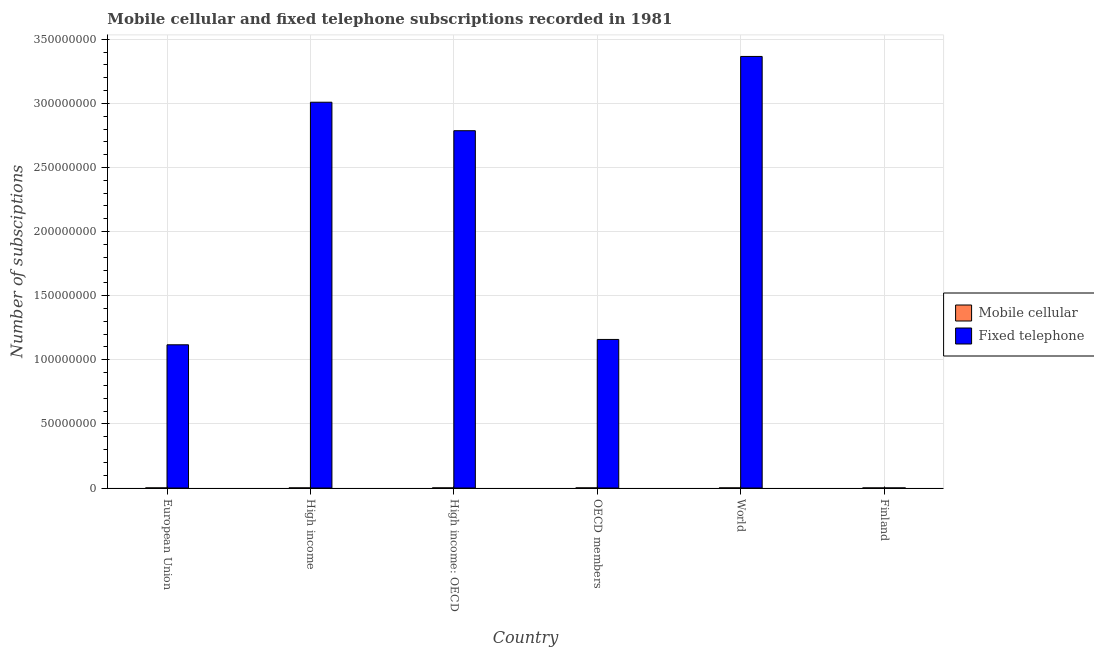How many different coloured bars are there?
Give a very brief answer. 2. Are the number of bars per tick equal to the number of legend labels?
Offer a very short reply. Yes. Are the number of bars on each tick of the X-axis equal?
Provide a succinct answer. Yes. How many bars are there on the 4th tick from the left?
Give a very brief answer. 2. What is the label of the 3rd group of bars from the left?
Offer a terse response. High income: OECD. What is the number of mobile cellular subscriptions in OECD members?
Keep it short and to the point. 6.36e+04. Across all countries, what is the maximum number of fixed telephone subscriptions?
Your answer should be very brief. 3.37e+08. Across all countries, what is the minimum number of fixed telephone subscriptions?
Your answer should be very brief. 3.71e+04. In which country was the number of fixed telephone subscriptions maximum?
Your answer should be compact. World. What is the total number of mobile cellular subscriptions in the graph?
Keep it short and to the point. 3.31e+05. What is the difference between the number of fixed telephone subscriptions in High income and that in High income: OECD?
Your answer should be compact. 2.22e+07. What is the difference between the number of fixed telephone subscriptions in OECD members and the number of mobile cellular subscriptions in Finland?
Offer a very short reply. 1.16e+08. What is the average number of mobile cellular subscriptions per country?
Offer a terse response. 5.52e+04. What is the difference between the number of fixed telephone subscriptions and number of mobile cellular subscriptions in Finland?
Your response must be concise. 8825. What is the ratio of the number of fixed telephone subscriptions in European Union to that in Finland?
Provide a short and direct response. 3010.64. What is the difference between the highest and the second highest number of mobile cellular subscriptions?
Provide a short and direct response. 0. What is the difference between the highest and the lowest number of fixed telephone subscriptions?
Your response must be concise. 3.37e+08. What does the 1st bar from the left in Finland represents?
Keep it short and to the point. Mobile cellular. What does the 2nd bar from the right in High income: OECD represents?
Provide a short and direct response. Mobile cellular. How many bars are there?
Your response must be concise. 12. What is the difference between two consecutive major ticks on the Y-axis?
Provide a short and direct response. 5.00e+07. Does the graph contain grids?
Your response must be concise. Yes. What is the title of the graph?
Give a very brief answer. Mobile cellular and fixed telephone subscriptions recorded in 1981. What is the label or title of the X-axis?
Give a very brief answer. Country. What is the label or title of the Y-axis?
Ensure brevity in your answer.  Number of subsciptions. What is the Number of subsciptions in Mobile cellular in European Union?
Keep it short and to the point. 4.86e+04. What is the Number of subsciptions in Fixed telephone in European Union?
Make the answer very short. 1.12e+08. What is the Number of subsciptions in Mobile cellular in High income?
Provide a short and direct response. 6.36e+04. What is the Number of subsciptions in Fixed telephone in High income?
Give a very brief answer. 3.01e+08. What is the Number of subsciptions of Mobile cellular in High income: OECD?
Your response must be concise. 6.36e+04. What is the Number of subsciptions of Fixed telephone in High income: OECD?
Ensure brevity in your answer.  2.79e+08. What is the Number of subsciptions of Mobile cellular in OECD members?
Ensure brevity in your answer.  6.36e+04. What is the Number of subsciptions of Fixed telephone in OECD members?
Ensure brevity in your answer.  1.16e+08. What is the Number of subsciptions of Mobile cellular in World?
Offer a very short reply. 6.36e+04. What is the Number of subsciptions in Fixed telephone in World?
Your answer should be compact. 3.37e+08. What is the Number of subsciptions of Mobile cellular in Finland?
Give a very brief answer. 2.83e+04. What is the Number of subsciptions in Fixed telephone in Finland?
Offer a terse response. 3.71e+04. Across all countries, what is the maximum Number of subsciptions in Mobile cellular?
Keep it short and to the point. 6.36e+04. Across all countries, what is the maximum Number of subsciptions in Fixed telephone?
Offer a terse response. 3.37e+08. Across all countries, what is the minimum Number of subsciptions of Mobile cellular?
Your answer should be very brief. 2.83e+04. Across all countries, what is the minimum Number of subsciptions in Fixed telephone?
Give a very brief answer. 3.71e+04. What is the total Number of subsciptions of Mobile cellular in the graph?
Offer a very short reply. 3.31e+05. What is the total Number of subsciptions of Fixed telephone in the graph?
Provide a short and direct response. 1.14e+09. What is the difference between the Number of subsciptions of Mobile cellular in European Union and that in High income?
Your answer should be very brief. -1.49e+04. What is the difference between the Number of subsciptions of Fixed telephone in European Union and that in High income?
Provide a succinct answer. -1.89e+08. What is the difference between the Number of subsciptions in Mobile cellular in European Union and that in High income: OECD?
Provide a succinct answer. -1.49e+04. What is the difference between the Number of subsciptions in Fixed telephone in European Union and that in High income: OECD?
Give a very brief answer. -1.67e+08. What is the difference between the Number of subsciptions in Mobile cellular in European Union and that in OECD members?
Give a very brief answer. -1.49e+04. What is the difference between the Number of subsciptions in Fixed telephone in European Union and that in OECD members?
Offer a very short reply. -4.17e+06. What is the difference between the Number of subsciptions of Mobile cellular in European Union and that in World?
Your answer should be compact. -1.49e+04. What is the difference between the Number of subsciptions in Fixed telephone in European Union and that in World?
Offer a very short reply. -2.25e+08. What is the difference between the Number of subsciptions in Mobile cellular in European Union and that in Finland?
Provide a short and direct response. 2.04e+04. What is the difference between the Number of subsciptions in Fixed telephone in European Union and that in Finland?
Offer a terse response. 1.12e+08. What is the difference between the Number of subsciptions in Fixed telephone in High income and that in High income: OECD?
Keep it short and to the point. 2.22e+07. What is the difference between the Number of subsciptions of Mobile cellular in High income and that in OECD members?
Your answer should be very brief. 0. What is the difference between the Number of subsciptions in Fixed telephone in High income and that in OECD members?
Your answer should be compact. 1.85e+08. What is the difference between the Number of subsciptions of Mobile cellular in High income and that in World?
Your answer should be very brief. 0. What is the difference between the Number of subsciptions in Fixed telephone in High income and that in World?
Give a very brief answer. -3.57e+07. What is the difference between the Number of subsciptions in Mobile cellular in High income and that in Finland?
Your answer should be compact. 3.53e+04. What is the difference between the Number of subsciptions in Fixed telephone in High income and that in Finland?
Give a very brief answer. 3.01e+08. What is the difference between the Number of subsciptions in Fixed telephone in High income: OECD and that in OECD members?
Offer a terse response. 1.63e+08. What is the difference between the Number of subsciptions in Fixed telephone in High income: OECD and that in World?
Offer a very short reply. -5.79e+07. What is the difference between the Number of subsciptions in Mobile cellular in High income: OECD and that in Finland?
Provide a short and direct response. 3.53e+04. What is the difference between the Number of subsciptions in Fixed telephone in High income: OECD and that in Finland?
Your answer should be compact. 2.79e+08. What is the difference between the Number of subsciptions of Mobile cellular in OECD members and that in World?
Provide a short and direct response. 0. What is the difference between the Number of subsciptions of Fixed telephone in OECD members and that in World?
Offer a terse response. -2.21e+08. What is the difference between the Number of subsciptions of Mobile cellular in OECD members and that in Finland?
Provide a succinct answer. 3.53e+04. What is the difference between the Number of subsciptions of Fixed telephone in OECD members and that in Finland?
Your answer should be very brief. 1.16e+08. What is the difference between the Number of subsciptions in Mobile cellular in World and that in Finland?
Offer a very short reply. 3.53e+04. What is the difference between the Number of subsciptions in Fixed telephone in World and that in Finland?
Make the answer very short. 3.37e+08. What is the difference between the Number of subsciptions in Mobile cellular in European Union and the Number of subsciptions in Fixed telephone in High income?
Your answer should be compact. -3.01e+08. What is the difference between the Number of subsciptions in Mobile cellular in European Union and the Number of subsciptions in Fixed telephone in High income: OECD?
Your response must be concise. -2.79e+08. What is the difference between the Number of subsciptions of Mobile cellular in European Union and the Number of subsciptions of Fixed telephone in OECD members?
Offer a terse response. -1.16e+08. What is the difference between the Number of subsciptions of Mobile cellular in European Union and the Number of subsciptions of Fixed telephone in World?
Make the answer very short. -3.37e+08. What is the difference between the Number of subsciptions of Mobile cellular in European Union and the Number of subsciptions of Fixed telephone in Finland?
Ensure brevity in your answer.  1.15e+04. What is the difference between the Number of subsciptions in Mobile cellular in High income and the Number of subsciptions in Fixed telephone in High income: OECD?
Offer a terse response. -2.79e+08. What is the difference between the Number of subsciptions of Mobile cellular in High income and the Number of subsciptions of Fixed telephone in OECD members?
Make the answer very short. -1.16e+08. What is the difference between the Number of subsciptions in Mobile cellular in High income and the Number of subsciptions in Fixed telephone in World?
Your answer should be very brief. -3.37e+08. What is the difference between the Number of subsciptions in Mobile cellular in High income and the Number of subsciptions in Fixed telephone in Finland?
Offer a very short reply. 2.65e+04. What is the difference between the Number of subsciptions in Mobile cellular in High income: OECD and the Number of subsciptions in Fixed telephone in OECD members?
Your answer should be very brief. -1.16e+08. What is the difference between the Number of subsciptions of Mobile cellular in High income: OECD and the Number of subsciptions of Fixed telephone in World?
Keep it short and to the point. -3.37e+08. What is the difference between the Number of subsciptions of Mobile cellular in High income: OECD and the Number of subsciptions of Fixed telephone in Finland?
Provide a short and direct response. 2.65e+04. What is the difference between the Number of subsciptions in Mobile cellular in OECD members and the Number of subsciptions in Fixed telephone in World?
Provide a succinct answer. -3.37e+08. What is the difference between the Number of subsciptions in Mobile cellular in OECD members and the Number of subsciptions in Fixed telephone in Finland?
Provide a succinct answer. 2.65e+04. What is the difference between the Number of subsciptions in Mobile cellular in World and the Number of subsciptions in Fixed telephone in Finland?
Make the answer very short. 2.65e+04. What is the average Number of subsciptions in Mobile cellular per country?
Offer a very short reply. 5.52e+04. What is the average Number of subsciptions of Fixed telephone per country?
Your answer should be compact. 1.91e+08. What is the difference between the Number of subsciptions of Mobile cellular and Number of subsciptions of Fixed telephone in European Union?
Give a very brief answer. -1.12e+08. What is the difference between the Number of subsciptions of Mobile cellular and Number of subsciptions of Fixed telephone in High income?
Your answer should be compact. -3.01e+08. What is the difference between the Number of subsciptions in Mobile cellular and Number of subsciptions in Fixed telephone in High income: OECD?
Your response must be concise. -2.79e+08. What is the difference between the Number of subsciptions in Mobile cellular and Number of subsciptions in Fixed telephone in OECD members?
Give a very brief answer. -1.16e+08. What is the difference between the Number of subsciptions in Mobile cellular and Number of subsciptions in Fixed telephone in World?
Provide a succinct answer. -3.37e+08. What is the difference between the Number of subsciptions in Mobile cellular and Number of subsciptions in Fixed telephone in Finland?
Offer a very short reply. -8825. What is the ratio of the Number of subsciptions of Mobile cellular in European Union to that in High income?
Ensure brevity in your answer.  0.77. What is the ratio of the Number of subsciptions in Fixed telephone in European Union to that in High income?
Keep it short and to the point. 0.37. What is the ratio of the Number of subsciptions in Mobile cellular in European Union to that in High income: OECD?
Make the answer very short. 0.77. What is the ratio of the Number of subsciptions of Fixed telephone in European Union to that in High income: OECD?
Make the answer very short. 0.4. What is the ratio of the Number of subsciptions of Mobile cellular in European Union to that in OECD members?
Give a very brief answer. 0.77. What is the ratio of the Number of subsciptions of Mobile cellular in European Union to that in World?
Provide a short and direct response. 0.77. What is the ratio of the Number of subsciptions of Fixed telephone in European Union to that in World?
Make the answer very short. 0.33. What is the ratio of the Number of subsciptions in Mobile cellular in European Union to that in Finland?
Ensure brevity in your answer.  1.72. What is the ratio of the Number of subsciptions in Fixed telephone in European Union to that in Finland?
Your answer should be compact. 3010.64. What is the ratio of the Number of subsciptions of Fixed telephone in High income to that in High income: OECD?
Make the answer very short. 1.08. What is the ratio of the Number of subsciptions of Mobile cellular in High income to that in OECD members?
Make the answer very short. 1. What is the ratio of the Number of subsciptions of Fixed telephone in High income to that in OECD members?
Your answer should be compact. 2.6. What is the ratio of the Number of subsciptions in Mobile cellular in High income to that in World?
Your response must be concise. 1. What is the ratio of the Number of subsciptions of Fixed telephone in High income to that in World?
Keep it short and to the point. 0.89. What is the ratio of the Number of subsciptions in Mobile cellular in High income to that in Finland?
Provide a short and direct response. 2.25. What is the ratio of the Number of subsciptions of Fixed telephone in High income to that in Finland?
Offer a very short reply. 8109.92. What is the ratio of the Number of subsciptions of Fixed telephone in High income: OECD to that in OECD members?
Your answer should be very brief. 2.41. What is the ratio of the Number of subsciptions in Mobile cellular in High income: OECD to that in World?
Provide a short and direct response. 1. What is the ratio of the Number of subsciptions in Fixed telephone in High income: OECD to that in World?
Your response must be concise. 0.83. What is the ratio of the Number of subsciptions of Mobile cellular in High income: OECD to that in Finland?
Your answer should be very brief. 2.25. What is the ratio of the Number of subsciptions in Fixed telephone in High income: OECD to that in Finland?
Make the answer very short. 7511.34. What is the ratio of the Number of subsciptions in Fixed telephone in OECD members to that in World?
Give a very brief answer. 0.34. What is the ratio of the Number of subsciptions of Mobile cellular in OECD members to that in Finland?
Give a very brief answer. 2.25. What is the ratio of the Number of subsciptions of Fixed telephone in OECD members to that in Finland?
Make the answer very short. 3123.12. What is the ratio of the Number of subsciptions of Mobile cellular in World to that in Finland?
Provide a succinct answer. 2.25. What is the ratio of the Number of subsciptions in Fixed telephone in World to that in Finland?
Provide a short and direct response. 9072.31. What is the difference between the highest and the second highest Number of subsciptions of Fixed telephone?
Offer a very short reply. 3.57e+07. What is the difference between the highest and the lowest Number of subsciptions of Mobile cellular?
Provide a succinct answer. 3.53e+04. What is the difference between the highest and the lowest Number of subsciptions of Fixed telephone?
Ensure brevity in your answer.  3.37e+08. 